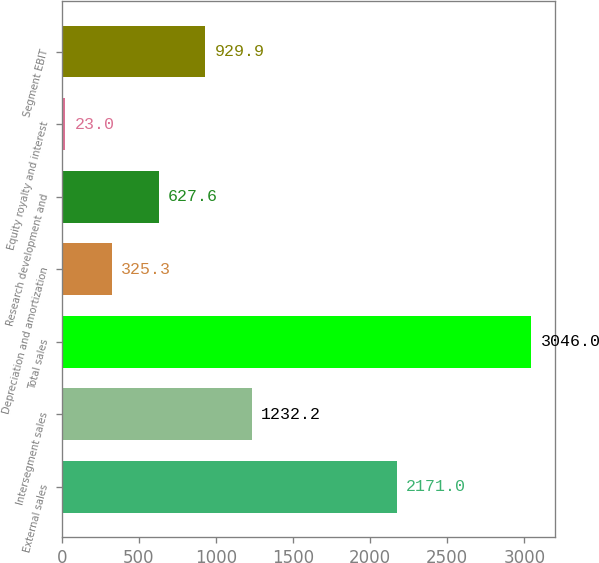Convert chart to OTSL. <chart><loc_0><loc_0><loc_500><loc_500><bar_chart><fcel>External sales<fcel>Intersegment sales<fcel>Total sales<fcel>Depreciation and amortization<fcel>Research development and<fcel>Equity royalty and interest<fcel>Segment EBIT<nl><fcel>2171<fcel>1232.2<fcel>3046<fcel>325.3<fcel>627.6<fcel>23<fcel>929.9<nl></chart> 